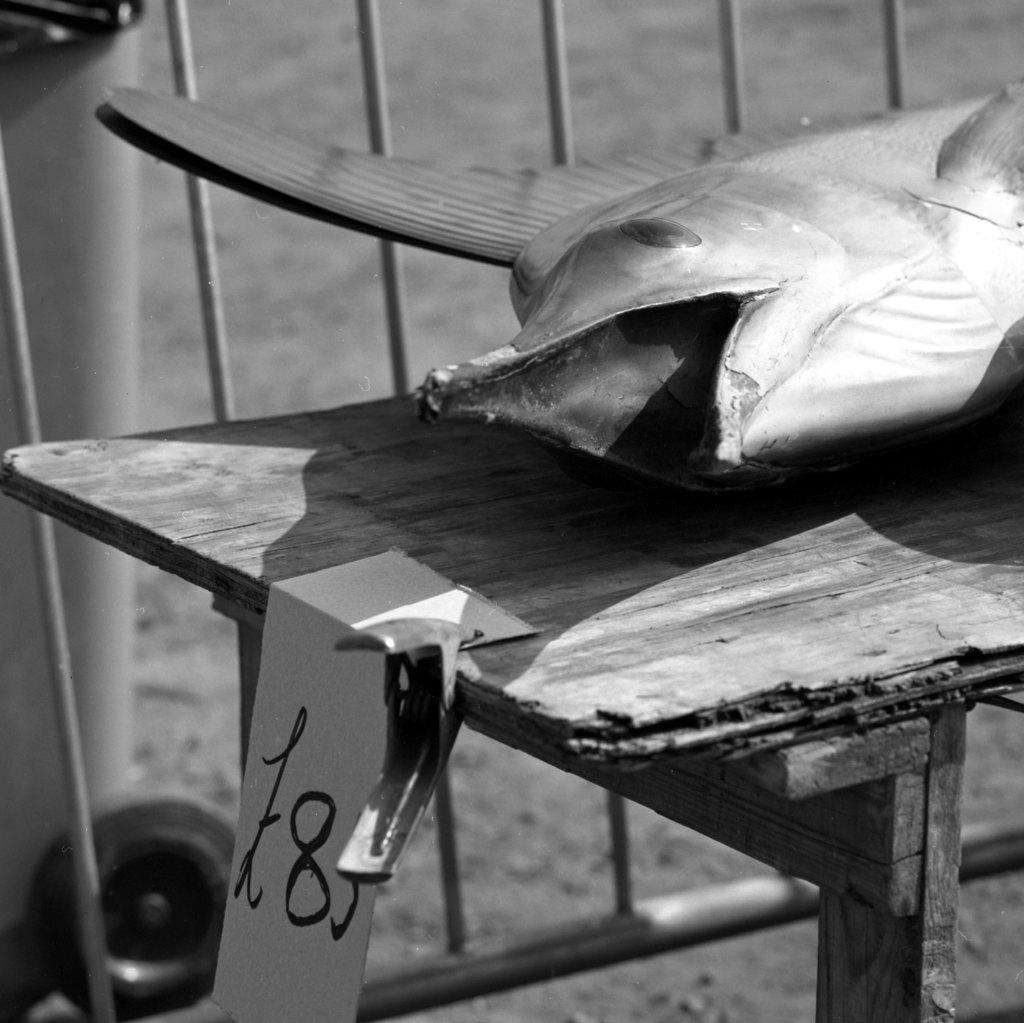What type of furniture is present in the image? There is a table in the image. What object is placed on the table? There is a toy fish on the table. What type of meal is being prepared on the table in the image? There is no meal being prepared in the image; it only features a table with a toy fish on it. How many horses are visible in the image? There are no horses present in the image. 